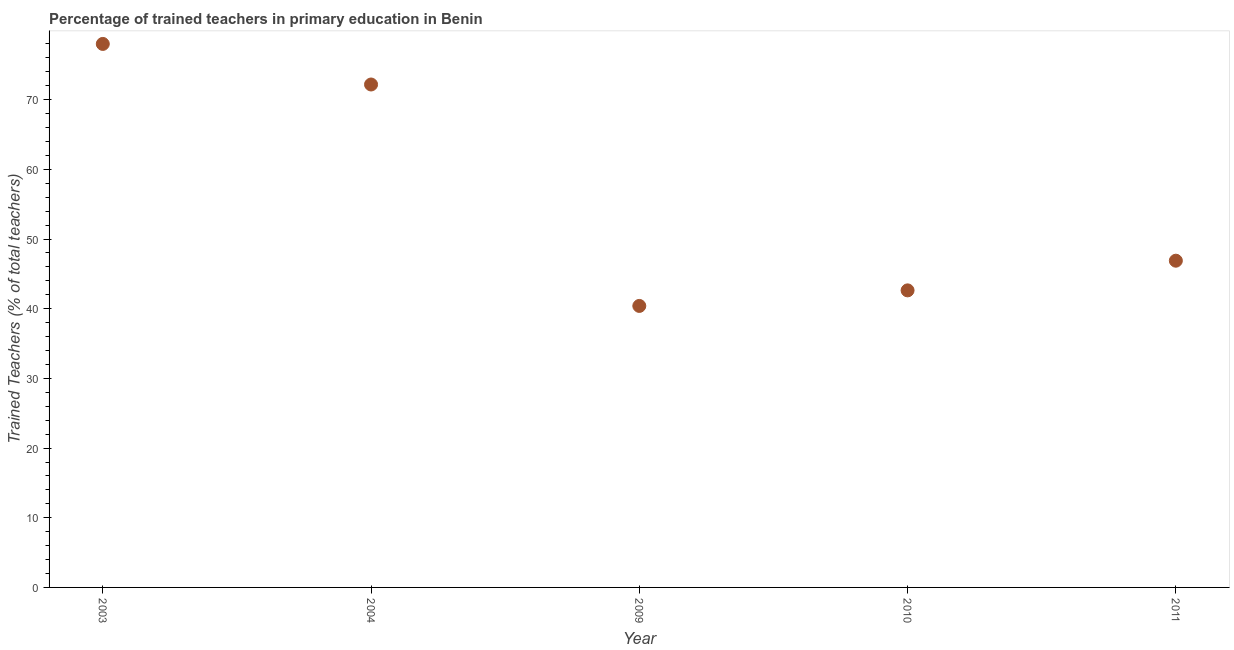What is the percentage of trained teachers in 2004?
Offer a very short reply. 72.18. Across all years, what is the maximum percentage of trained teachers?
Give a very brief answer. 78. Across all years, what is the minimum percentage of trained teachers?
Give a very brief answer. 40.4. What is the sum of the percentage of trained teachers?
Your response must be concise. 280.1. What is the difference between the percentage of trained teachers in 2009 and 2010?
Your answer should be very brief. -2.23. What is the average percentage of trained teachers per year?
Make the answer very short. 56.02. What is the median percentage of trained teachers?
Provide a succinct answer. 46.89. Do a majority of the years between 2004 and 2003 (inclusive) have percentage of trained teachers greater than 34 %?
Ensure brevity in your answer.  No. What is the ratio of the percentage of trained teachers in 2003 to that in 2009?
Give a very brief answer. 1.93. Is the percentage of trained teachers in 2010 less than that in 2011?
Provide a succinct answer. Yes. Is the difference between the percentage of trained teachers in 2009 and 2011 greater than the difference between any two years?
Ensure brevity in your answer.  No. What is the difference between the highest and the second highest percentage of trained teachers?
Your response must be concise. 5.82. What is the difference between the highest and the lowest percentage of trained teachers?
Keep it short and to the point. 37.6. In how many years, is the percentage of trained teachers greater than the average percentage of trained teachers taken over all years?
Provide a short and direct response. 2. How many years are there in the graph?
Provide a succinct answer. 5. What is the difference between two consecutive major ticks on the Y-axis?
Your response must be concise. 10. Are the values on the major ticks of Y-axis written in scientific E-notation?
Ensure brevity in your answer.  No. Does the graph contain grids?
Your answer should be very brief. No. What is the title of the graph?
Give a very brief answer. Percentage of trained teachers in primary education in Benin. What is the label or title of the X-axis?
Ensure brevity in your answer.  Year. What is the label or title of the Y-axis?
Give a very brief answer. Trained Teachers (% of total teachers). What is the Trained Teachers (% of total teachers) in 2003?
Provide a short and direct response. 78. What is the Trained Teachers (% of total teachers) in 2004?
Provide a succinct answer. 72.18. What is the Trained Teachers (% of total teachers) in 2009?
Provide a succinct answer. 40.4. What is the Trained Teachers (% of total teachers) in 2010?
Keep it short and to the point. 42.63. What is the Trained Teachers (% of total teachers) in 2011?
Your answer should be compact. 46.89. What is the difference between the Trained Teachers (% of total teachers) in 2003 and 2004?
Provide a succinct answer. 5.82. What is the difference between the Trained Teachers (% of total teachers) in 2003 and 2009?
Offer a very short reply. 37.6. What is the difference between the Trained Teachers (% of total teachers) in 2003 and 2010?
Make the answer very short. 35.37. What is the difference between the Trained Teachers (% of total teachers) in 2003 and 2011?
Your answer should be very brief. 31.11. What is the difference between the Trained Teachers (% of total teachers) in 2004 and 2009?
Offer a terse response. 31.78. What is the difference between the Trained Teachers (% of total teachers) in 2004 and 2010?
Keep it short and to the point. 29.55. What is the difference between the Trained Teachers (% of total teachers) in 2004 and 2011?
Your response must be concise. 25.29. What is the difference between the Trained Teachers (% of total teachers) in 2009 and 2010?
Make the answer very short. -2.23. What is the difference between the Trained Teachers (% of total teachers) in 2009 and 2011?
Give a very brief answer. -6.49. What is the difference between the Trained Teachers (% of total teachers) in 2010 and 2011?
Your response must be concise. -4.26. What is the ratio of the Trained Teachers (% of total teachers) in 2003 to that in 2004?
Provide a short and direct response. 1.08. What is the ratio of the Trained Teachers (% of total teachers) in 2003 to that in 2009?
Give a very brief answer. 1.93. What is the ratio of the Trained Teachers (% of total teachers) in 2003 to that in 2010?
Your response must be concise. 1.83. What is the ratio of the Trained Teachers (% of total teachers) in 2003 to that in 2011?
Offer a very short reply. 1.66. What is the ratio of the Trained Teachers (% of total teachers) in 2004 to that in 2009?
Offer a very short reply. 1.79. What is the ratio of the Trained Teachers (% of total teachers) in 2004 to that in 2010?
Your answer should be very brief. 1.69. What is the ratio of the Trained Teachers (% of total teachers) in 2004 to that in 2011?
Your answer should be compact. 1.54. What is the ratio of the Trained Teachers (% of total teachers) in 2009 to that in 2010?
Give a very brief answer. 0.95. What is the ratio of the Trained Teachers (% of total teachers) in 2009 to that in 2011?
Ensure brevity in your answer.  0.86. What is the ratio of the Trained Teachers (% of total teachers) in 2010 to that in 2011?
Offer a very short reply. 0.91. 